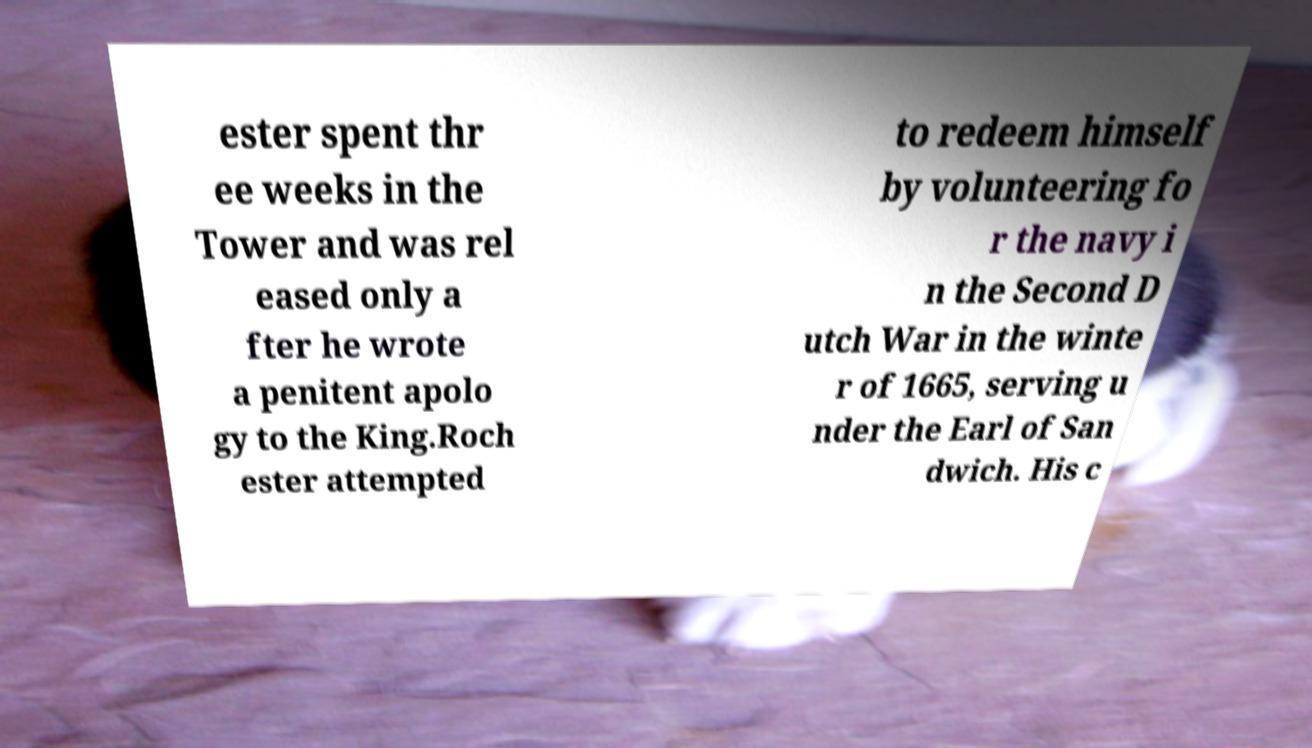What messages or text are displayed in this image? I need them in a readable, typed format. ester spent thr ee weeks in the Tower and was rel eased only a fter he wrote a penitent apolo gy to the King.Roch ester attempted to redeem himself by volunteering fo r the navy i n the Second D utch War in the winte r of 1665, serving u nder the Earl of San dwich. His c 